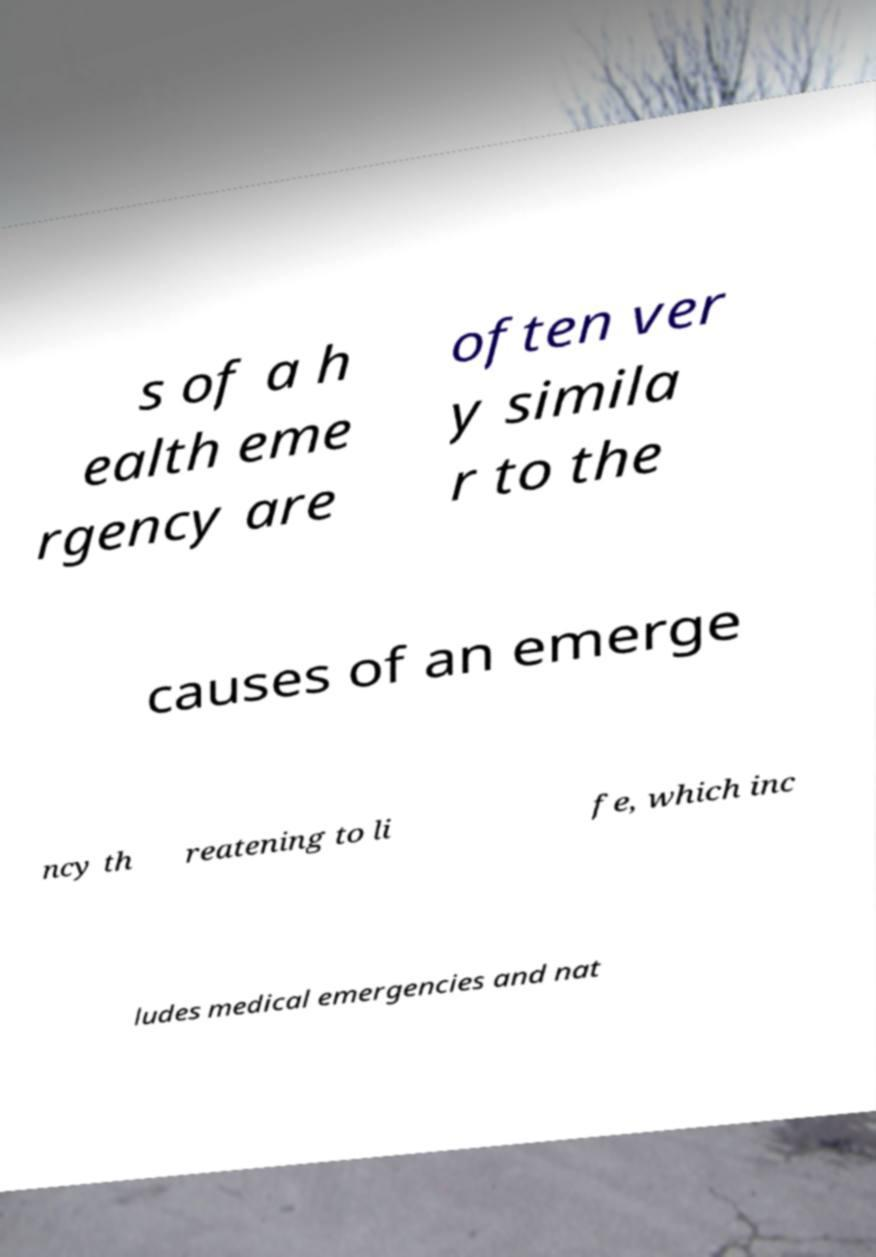I need the written content from this picture converted into text. Can you do that? s of a h ealth eme rgency are often ver y simila r to the causes of an emerge ncy th reatening to li fe, which inc ludes medical emergencies and nat 